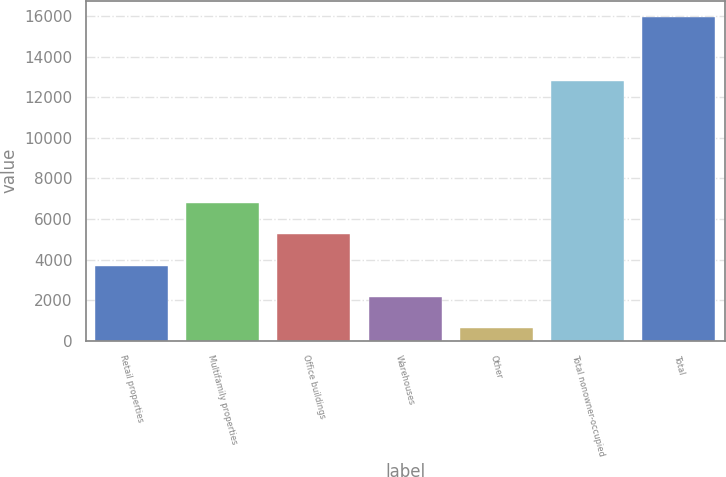Convert chart. <chart><loc_0><loc_0><loc_500><loc_500><bar_chart><fcel>Retail properties<fcel>Multifamily properties<fcel>Office buildings<fcel>Warehouses<fcel>Other<fcel>Total nonowner-occupied<fcel>Total<nl><fcel>3707.8<fcel>6768.6<fcel>5238.2<fcel>2177.4<fcel>647<fcel>12816<fcel>15951<nl></chart> 